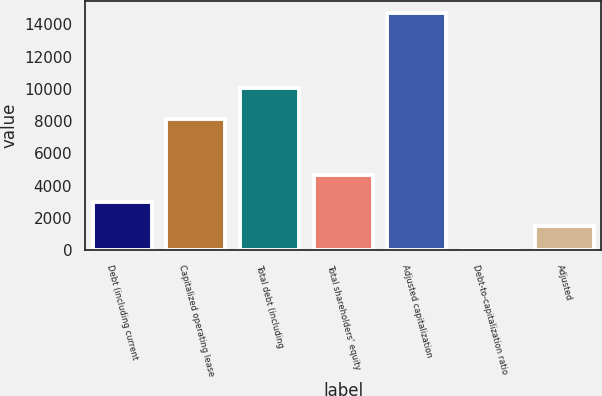Convert chart. <chart><loc_0><loc_0><loc_500><loc_500><bar_chart><fcel>Debt (including current<fcel>Capitalized operating lease<fcel>Total debt (including<fcel>Total shareholders' equity<fcel>Adjusted capitalization<fcel>Debt-to-capitalization ratio<fcel>Adjusted<nl><fcel>2968<fcel>8114<fcel>10077<fcel>4643<fcel>14720<fcel>30<fcel>1499<nl></chart> 